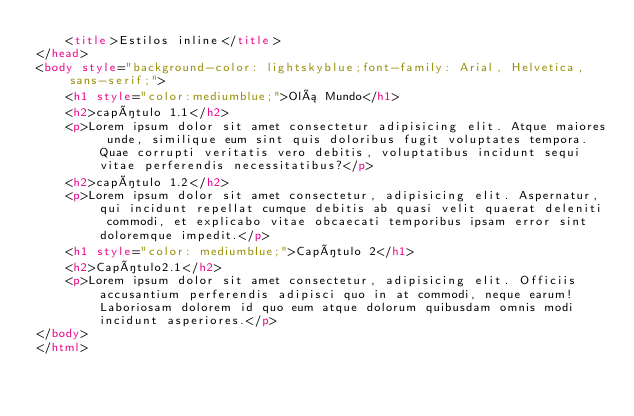Convert code to text. <code><loc_0><loc_0><loc_500><loc_500><_HTML_>    <title>Estilos inline</title>
</head>
<body style="background-color: lightskyblue;font-family: Arial, Helvetica, sans-serif;">
    <h1 style="color:mediumblue;">Olá Mundo</h1>
    <h2>capítulo 1.1</h2>
    <p>Lorem ipsum dolor sit amet consectetur adipisicing elit. Atque maiores unde, similique eum sint quis doloribus fugit voluptates tempora. Quae corrupti veritatis vero debitis, voluptatibus incidunt sequi vitae perferendis necessitatibus?</p>
    <h2>capítulo 1.2</h2>
    <p>Lorem ipsum dolor sit amet consectetur, adipisicing elit. Aspernatur, qui incidunt repellat cumque debitis ab quasi velit quaerat deleniti commodi, et explicabo vitae obcaecati temporibus ipsam error sint doloremque impedit.</p>
    <h1 style="color: mediumblue;">Capítulo 2</h1>
    <h2>Capítulo2.1</h2>
    <p>Lorem ipsum dolor sit amet consectetur, adipisicing elit. Officiis accusantium perferendis adipisci quo in at commodi, neque earum! Laboriosam dolorem id quo eum atque dolorum quibusdam omnis modi incidunt asperiores.</p>
</body>
</html></code> 